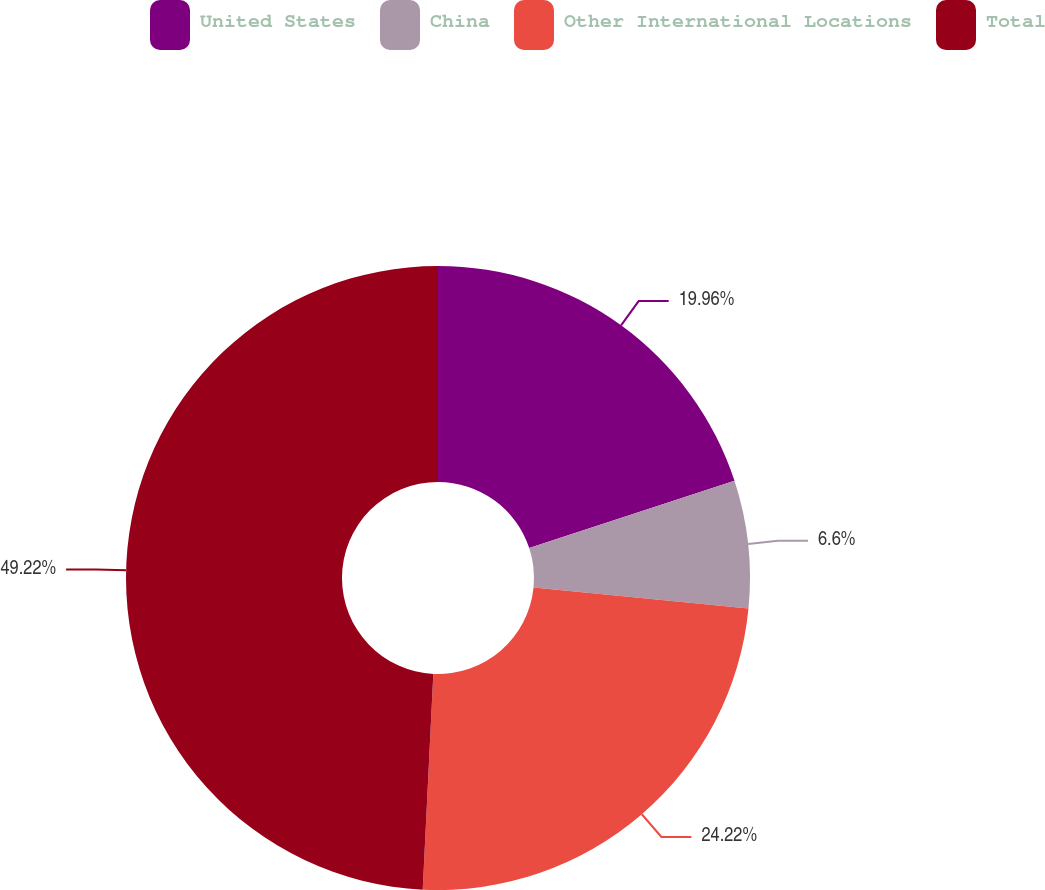Convert chart to OTSL. <chart><loc_0><loc_0><loc_500><loc_500><pie_chart><fcel>United States<fcel>China<fcel>Other International Locations<fcel>Total<nl><fcel>19.96%<fcel>6.6%<fcel>24.22%<fcel>49.22%<nl></chart> 